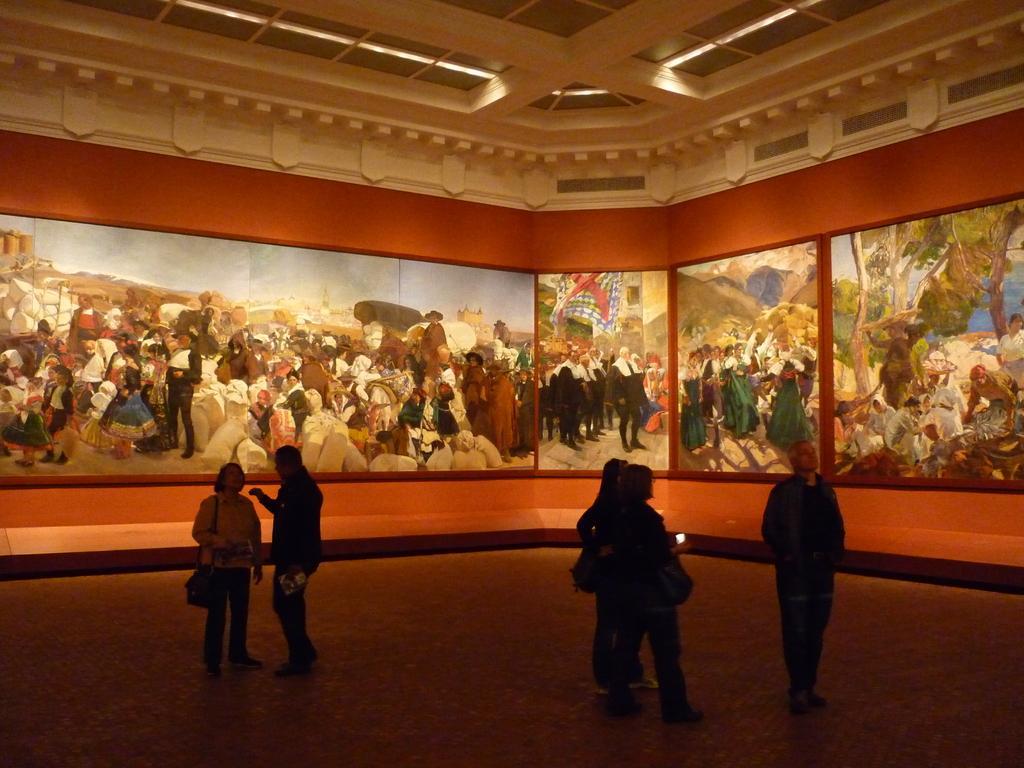Please provide a concise description of this image. This picture is clicked inside the hall. In the center we can see the group of persons and we can see the sling bags and some other objects. In the background we can see the wall and pictures of group of persons, trees, sky and some other objects. At the top there is a roof and the ceiling lights. 